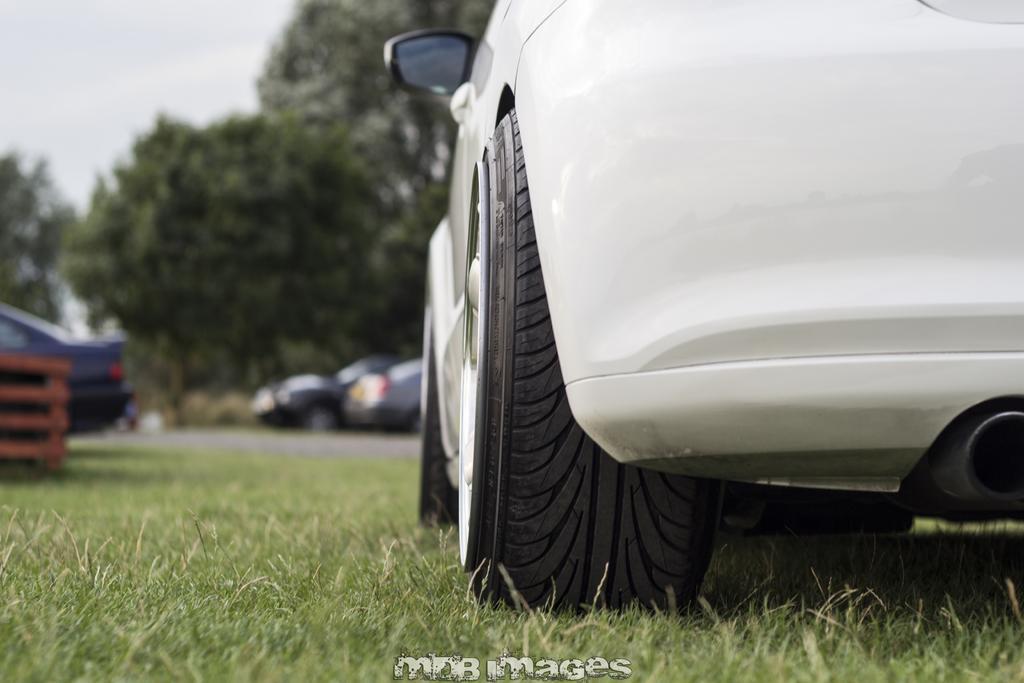In one or two sentences, can you explain what this image depicts? In this picture we can see cars and grass. In the background there are trees and sky. At the bottom we can see a watermark. 